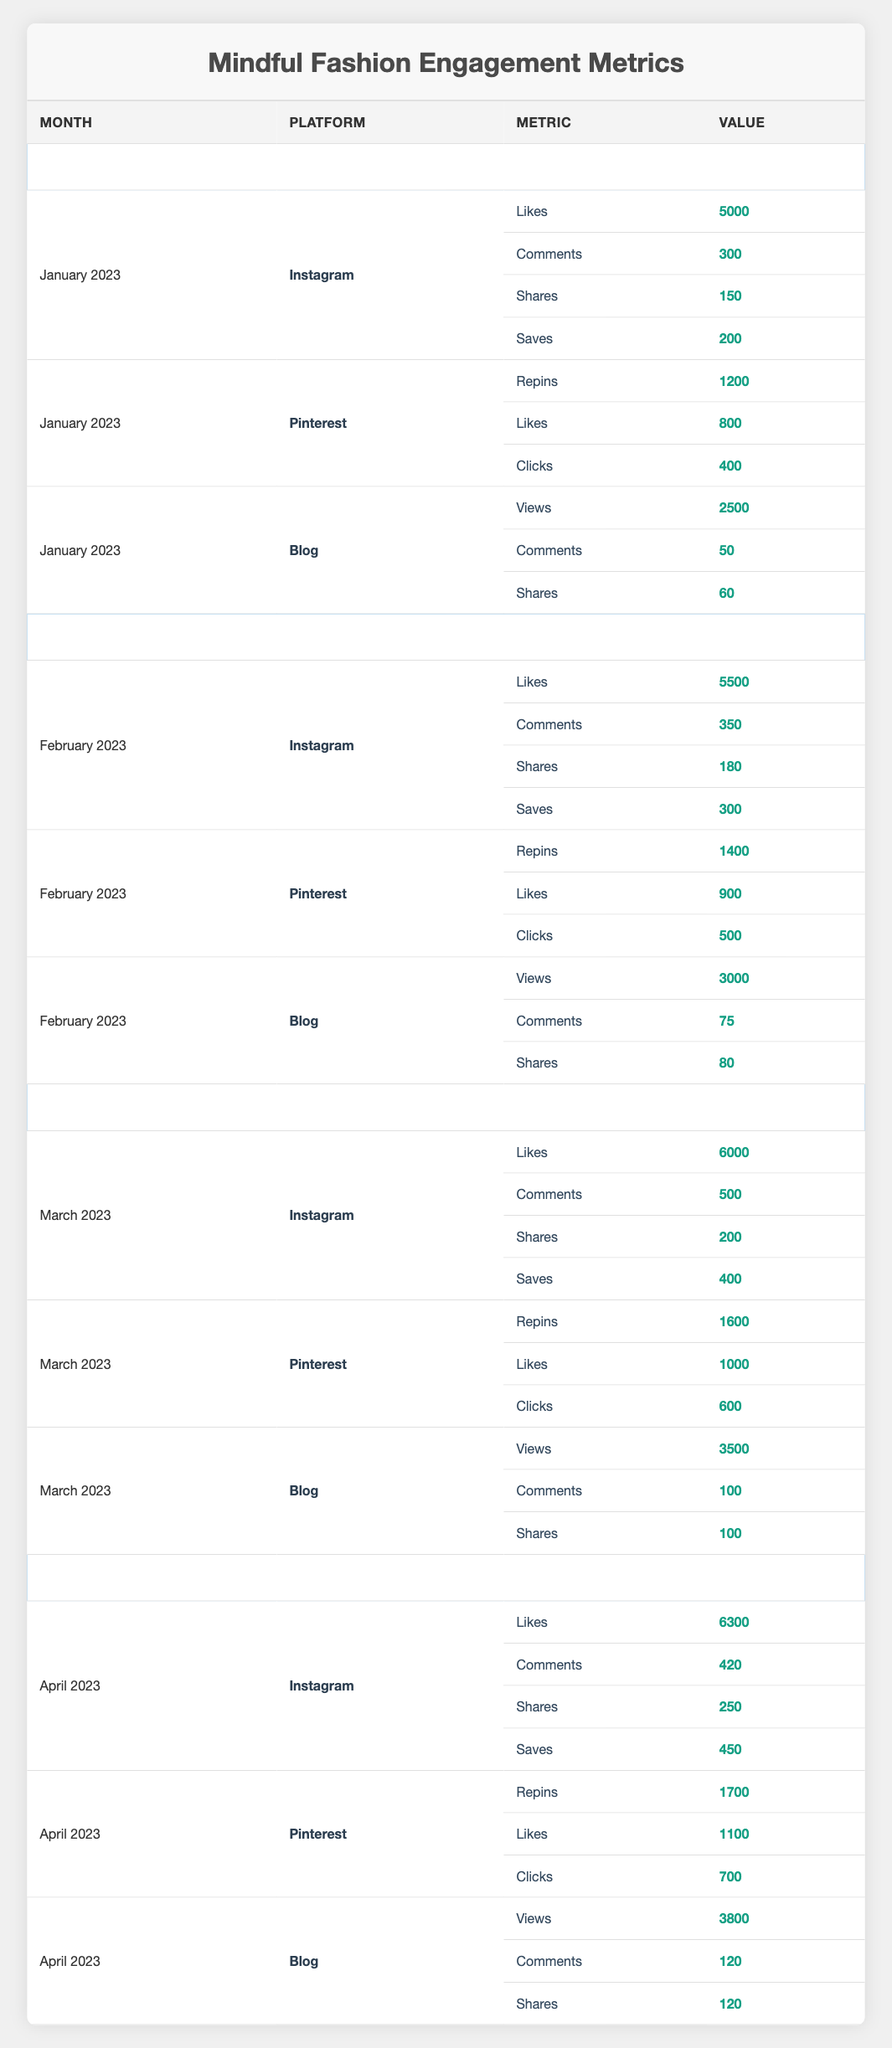What was the total number of Instagram Likes for January 2023? The table shows that in January 2023, Instagram received 5000 Likes. Therefore, the total number of Instagram Likes for that month is simply 5000.
Answer: 5000 How many total Shares were there across all platforms for February 2023? In February 2023, Instagram had 180 Shares, Pinterest had 0 Shares listed, and the Blog had 80 Shares. Adding these numbers gives us a total of 180 + 0 + 80 = 260 Shares for February 2023.
Answer: 260 Did the number of Blog Views increase each month from January to April 2023? Looking at the table, the Blog Views were 2500 in January, 3000 in February, 3500 in March, and 3800 in April. The numbers show a consistent increase each month, confirming that Blog Views did indeed increase every month.
Answer: Yes What is the average number of Comments on Instagram posts across the first four months of 2023? Totalling the Comments for Instagram: January (300), February (350), March (500), and April (420) gives 300 + 350 + 500 + 420 = 1570 Comments. Dividing this total by 4 (the number of months) results in an average of 1570 / 4 = 392.5.
Answer: 392.5 Which month had the highest total engagement (Likes, Comments, Shares, and Saves) on Instagram? For January, the total was 5000 Likes + 300 Comments + 150 Shares + 200 Saves = 5650. For February, it was 5500 + 350 + 180 + 300 = 6330. For March, it was 6000 + 500 + 200 + 400 = 6900. For April, it was 6300 + 420 + 250 + 450 = 7900. The month with the highest total engagement is April 2023 with 7900.
Answer: April 2023 